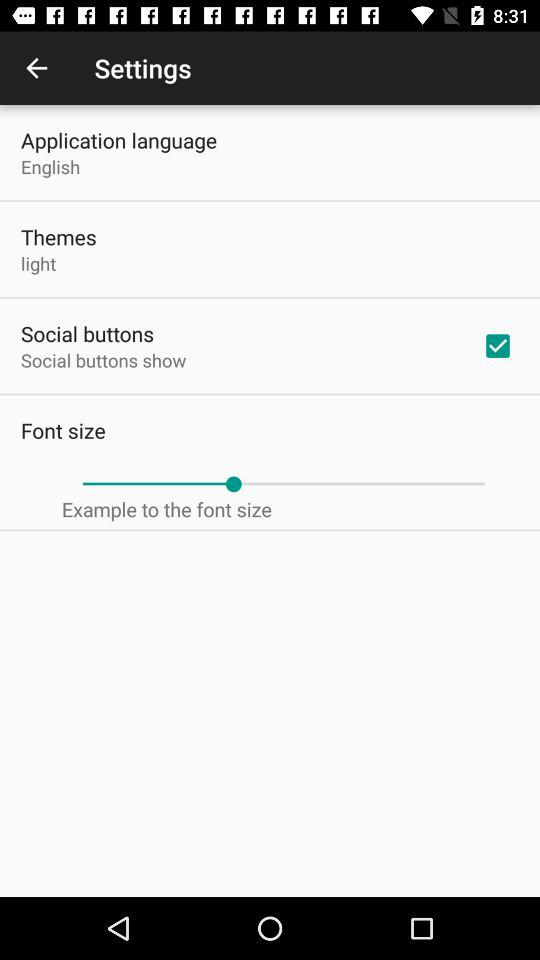What is the status of "Social buttons"? The status of "Social buttons" is "on". 